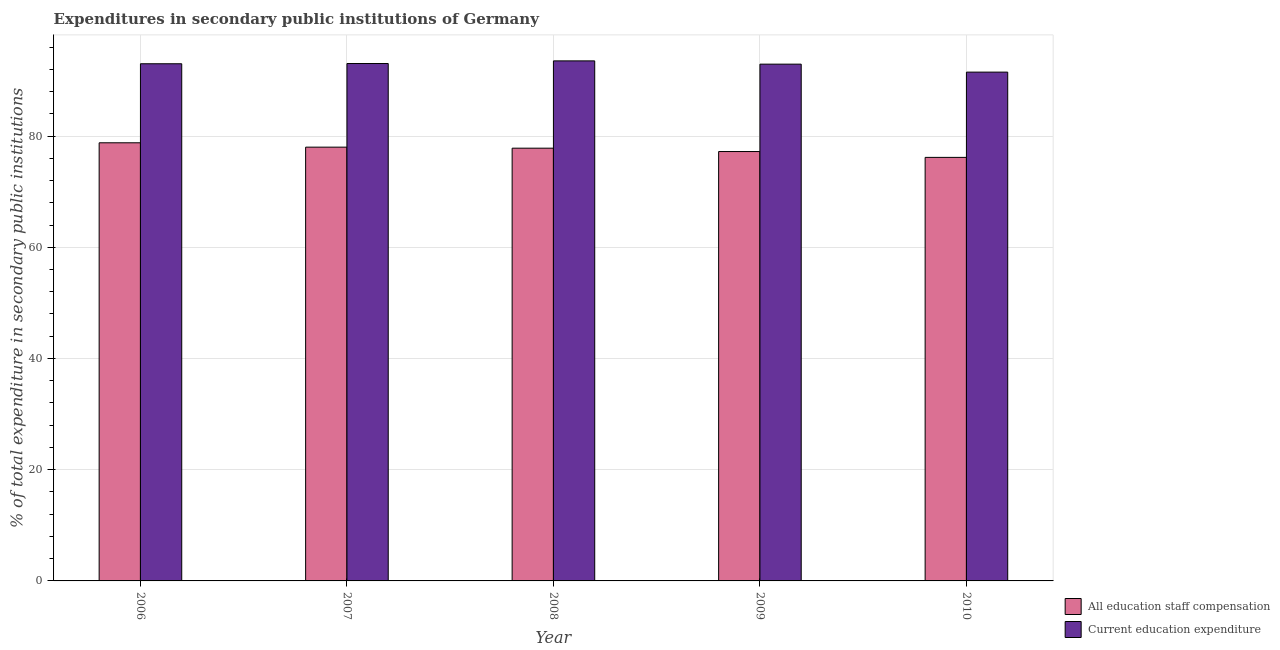How many groups of bars are there?
Make the answer very short. 5. How many bars are there on the 2nd tick from the left?
Give a very brief answer. 2. How many bars are there on the 2nd tick from the right?
Ensure brevity in your answer.  2. In how many cases, is the number of bars for a given year not equal to the number of legend labels?
Provide a short and direct response. 0. What is the expenditure in education in 2010?
Keep it short and to the point. 91.49. Across all years, what is the maximum expenditure in staff compensation?
Provide a succinct answer. 78.78. Across all years, what is the minimum expenditure in staff compensation?
Keep it short and to the point. 76.16. In which year was the expenditure in education minimum?
Your answer should be very brief. 2010. What is the total expenditure in education in the graph?
Make the answer very short. 463.96. What is the difference between the expenditure in education in 2006 and that in 2008?
Ensure brevity in your answer.  -0.52. What is the difference between the expenditure in staff compensation in 2010 and the expenditure in education in 2009?
Provide a short and direct response. -1.05. What is the average expenditure in education per year?
Provide a succinct answer. 92.79. What is the ratio of the expenditure in staff compensation in 2009 to that in 2010?
Provide a short and direct response. 1.01. What is the difference between the highest and the second highest expenditure in education?
Provide a succinct answer. 0.47. What is the difference between the highest and the lowest expenditure in education?
Make the answer very short. 2.02. Is the sum of the expenditure in staff compensation in 2008 and 2010 greater than the maximum expenditure in education across all years?
Make the answer very short. Yes. What does the 1st bar from the left in 2009 represents?
Your response must be concise. All education staff compensation. What does the 1st bar from the right in 2009 represents?
Give a very brief answer. Current education expenditure. How many years are there in the graph?
Give a very brief answer. 5. What is the difference between two consecutive major ticks on the Y-axis?
Provide a succinct answer. 20. Are the values on the major ticks of Y-axis written in scientific E-notation?
Give a very brief answer. No. Does the graph contain grids?
Give a very brief answer. Yes. How many legend labels are there?
Keep it short and to the point. 2. How are the legend labels stacked?
Your answer should be very brief. Vertical. What is the title of the graph?
Provide a succinct answer. Expenditures in secondary public institutions of Germany. Does "Under-5(female)" appear as one of the legend labels in the graph?
Offer a very short reply. No. What is the label or title of the Y-axis?
Provide a short and direct response. % of total expenditure in secondary public institutions. What is the % of total expenditure in secondary public institutions of All education staff compensation in 2006?
Keep it short and to the point. 78.78. What is the % of total expenditure in secondary public institutions of Current education expenditure in 2006?
Your answer should be very brief. 92.99. What is the % of total expenditure in secondary public institutions in All education staff compensation in 2007?
Keep it short and to the point. 78. What is the % of total expenditure in secondary public institutions of Current education expenditure in 2007?
Your response must be concise. 93.04. What is the % of total expenditure in secondary public institutions of All education staff compensation in 2008?
Your response must be concise. 77.81. What is the % of total expenditure in secondary public institutions of Current education expenditure in 2008?
Your answer should be very brief. 93.51. What is the % of total expenditure in secondary public institutions in All education staff compensation in 2009?
Keep it short and to the point. 77.21. What is the % of total expenditure in secondary public institutions in Current education expenditure in 2009?
Offer a very short reply. 92.92. What is the % of total expenditure in secondary public institutions of All education staff compensation in 2010?
Keep it short and to the point. 76.16. What is the % of total expenditure in secondary public institutions in Current education expenditure in 2010?
Offer a terse response. 91.49. Across all years, what is the maximum % of total expenditure in secondary public institutions in All education staff compensation?
Keep it short and to the point. 78.78. Across all years, what is the maximum % of total expenditure in secondary public institutions in Current education expenditure?
Your response must be concise. 93.51. Across all years, what is the minimum % of total expenditure in secondary public institutions in All education staff compensation?
Provide a succinct answer. 76.16. Across all years, what is the minimum % of total expenditure in secondary public institutions in Current education expenditure?
Your answer should be very brief. 91.49. What is the total % of total expenditure in secondary public institutions in All education staff compensation in the graph?
Provide a short and direct response. 387.96. What is the total % of total expenditure in secondary public institutions of Current education expenditure in the graph?
Your answer should be compact. 463.96. What is the difference between the % of total expenditure in secondary public institutions of All education staff compensation in 2006 and that in 2007?
Give a very brief answer. 0.78. What is the difference between the % of total expenditure in secondary public institutions of Current education expenditure in 2006 and that in 2007?
Provide a succinct answer. -0.04. What is the difference between the % of total expenditure in secondary public institutions in All education staff compensation in 2006 and that in 2008?
Your response must be concise. 0.97. What is the difference between the % of total expenditure in secondary public institutions in Current education expenditure in 2006 and that in 2008?
Your answer should be very brief. -0.52. What is the difference between the % of total expenditure in secondary public institutions in All education staff compensation in 2006 and that in 2009?
Offer a very short reply. 1.57. What is the difference between the % of total expenditure in secondary public institutions in Current education expenditure in 2006 and that in 2009?
Your response must be concise. 0.07. What is the difference between the % of total expenditure in secondary public institutions of All education staff compensation in 2006 and that in 2010?
Ensure brevity in your answer.  2.62. What is the difference between the % of total expenditure in secondary public institutions of Current education expenditure in 2006 and that in 2010?
Provide a succinct answer. 1.5. What is the difference between the % of total expenditure in secondary public institutions of All education staff compensation in 2007 and that in 2008?
Offer a terse response. 0.18. What is the difference between the % of total expenditure in secondary public institutions of Current education expenditure in 2007 and that in 2008?
Offer a terse response. -0.47. What is the difference between the % of total expenditure in secondary public institutions in All education staff compensation in 2007 and that in 2009?
Provide a succinct answer. 0.79. What is the difference between the % of total expenditure in secondary public institutions of Current education expenditure in 2007 and that in 2009?
Ensure brevity in your answer.  0.11. What is the difference between the % of total expenditure in secondary public institutions in All education staff compensation in 2007 and that in 2010?
Your response must be concise. 1.84. What is the difference between the % of total expenditure in secondary public institutions in Current education expenditure in 2007 and that in 2010?
Provide a succinct answer. 1.55. What is the difference between the % of total expenditure in secondary public institutions of All education staff compensation in 2008 and that in 2009?
Offer a terse response. 0.61. What is the difference between the % of total expenditure in secondary public institutions of Current education expenditure in 2008 and that in 2009?
Provide a succinct answer. 0.59. What is the difference between the % of total expenditure in secondary public institutions in All education staff compensation in 2008 and that in 2010?
Offer a very short reply. 1.66. What is the difference between the % of total expenditure in secondary public institutions in Current education expenditure in 2008 and that in 2010?
Provide a succinct answer. 2.02. What is the difference between the % of total expenditure in secondary public institutions in All education staff compensation in 2009 and that in 2010?
Make the answer very short. 1.05. What is the difference between the % of total expenditure in secondary public institutions of Current education expenditure in 2009 and that in 2010?
Give a very brief answer. 1.43. What is the difference between the % of total expenditure in secondary public institutions of All education staff compensation in 2006 and the % of total expenditure in secondary public institutions of Current education expenditure in 2007?
Ensure brevity in your answer.  -14.25. What is the difference between the % of total expenditure in secondary public institutions in All education staff compensation in 2006 and the % of total expenditure in secondary public institutions in Current education expenditure in 2008?
Offer a terse response. -14.73. What is the difference between the % of total expenditure in secondary public institutions of All education staff compensation in 2006 and the % of total expenditure in secondary public institutions of Current education expenditure in 2009?
Your response must be concise. -14.14. What is the difference between the % of total expenditure in secondary public institutions of All education staff compensation in 2006 and the % of total expenditure in secondary public institutions of Current education expenditure in 2010?
Provide a short and direct response. -12.71. What is the difference between the % of total expenditure in secondary public institutions of All education staff compensation in 2007 and the % of total expenditure in secondary public institutions of Current education expenditure in 2008?
Give a very brief answer. -15.51. What is the difference between the % of total expenditure in secondary public institutions in All education staff compensation in 2007 and the % of total expenditure in secondary public institutions in Current education expenditure in 2009?
Your answer should be compact. -14.93. What is the difference between the % of total expenditure in secondary public institutions in All education staff compensation in 2007 and the % of total expenditure in secondary public institutions in Current education expenditure in 2010?
Provide a short and direct response. -13.49. What is the difference between the % of total expenditure in secondary public institutions in All education staff compensation in 2008 and the % of total expenditure in secondary public institutions in Current education expenditure in 2009?
Make the answer very short. -15.11. What is the difference between the % of total expenditure in secondary public institutions of All education staff compensation in 2008 and the % of total expenditure in secondary public institutions of Current education expenditure in 2010?
Provide a succinct answer. -13.68. What is the difference between the % of total expenditure in secondary public institutions of All education staff compensation in 2009 and the % of total expenditure in secondary public institutions of Current education expenditure in 2010?
Your answer should be very brief. -14.28. What is the average % of total expenditure in secondary public institutions of All education staff compensation per year?
Provide a succinct answer. 77.59. What is the average % of total expenditure in secondary public institutions of Current education expenditure per year?
Your response must be concise. 92.79. In the year 2006, what is the difference between the % of total expenditure in secondary public institutions of All education staff compensation and % of total expenditure in secondary public institutions of Current education expenditure?
Keep it short and to the point. -14.21. In the year 2007, what is the difference between the % of total expenditure in secondary public institutions of All education staff compensation and % of total expenditure in secondary public institutions of Current education expenditure?
Your response must be concise. -15.04. In the year 2008, what is the difference between the % of total expenditure in secondary public institutions of All education staff compensation and % of total expenditure in secondary public institutions of Current education expenditure?
Offer a terse response. -15.7. In the year 2009, what is the difference between the % of total expenditure in secondary public institutions of All education staff compensation and % of total expenditure in secondary public institutions of Current education expenditure?
Your answer should be compact. -15.72. In the year 2010, what is the difference between the % of total expenditure in secondary public institutions of All education staff compensation and % of total expenditure in secondary public institutions of Current education expenditure?
Keep it short and to the point. -15.33. What is the ratio of the % of total expenditure in secondary public institutions in Current education expenditure in 2006 to that in 2007?
Provide a succinct answer. 1. What is the ratio of the % of total expenditure in secondary public institutions in All education staff compensation in 2006 to that in 2008?
Ensure brevity in your answer.  1.01. What is the ratio of the % of total expenditure in secondary public institutions of All education staff compensation in 2006 to that in 2009?
Provide a short and direct response. 1.02. What is the ratio of the % of total expenditure in secondary public institutions of All education staff compensation in 2006 to that in 2010?
Your answer should be compact. 1.03. What is the ratio of the % of total expenditure in secondary public institutions of Current education expenditure in 2006 to that in 2010?
Your answer should be compact. 1.02. What is the ratio of the % of total expenditure in secondary public institutions in All education staff compensation in 2007 to that in 2008?
Ensure brevity in your answer.  1. What is the ratio of the % of total expenditure in secondary public institutions in Current education expenditure in 2007 to that in 2008?
Offer a very short reply. 0.99. What is the ratio of the % of total expenditure in secondary public institutions of All education staff compensation in 2007 to that in 2009?
Give a very brief answer. 1.01. What is the ratio of the % of total expenditure in secondary public institutions in All education staff compensation in 2007 to that in 2010?
Your answer should be very brief. 1.02. What is the ratio of the % of total expenditure in secondary public institutions of Current education expenditure in 2007 to that in 2010?
Your answer should be compact. 1.02. What is the ratio of the % of total expenditure in secondary public institutions of Current education expenditure in 2008 to that in 2009?
Give a very brief answer. 1.01. What is the ratio of the % of total expenditure in secondary public institutions of All education staff compensation in 2008 to that in 2010?
Your response must be concise. 1.02. What is the ratio of the % of total expenditure in secondary public institutions in Current education expenditure in 2008 to that in 2010?
Offer a terse response. 1.02. What is the ratio of the % of total expenditure in secondary public institutions in All education staff compensation in 2009 to that in 2010?
Make the answer very short. 1.01. What is the ratio of the % of total expenditure in secondary public institutions of Current education expenditure in 2009 to that in 2010?
Your response must be concise. 1.02. What is the difference between the highest and the second highest % of total expenditure in secondary public institutions in All education staff compensation?
Give a very brief answer. 0.78. What is the difference between the highest and the second highest % of total expenditure in secondary public institutions in Current education expenditure?
Your response must be concise. 0.47. What is the difference between the highest and the lowest % of total expenditure in secondary public institutions of All education staff compensation?
Your response must be concise. 2.62. What is the difference between the highest and the lowest % of total expenditure in secondary public institutions in Current education expenditure?
Ensure brevity in your answer.  2.02. 